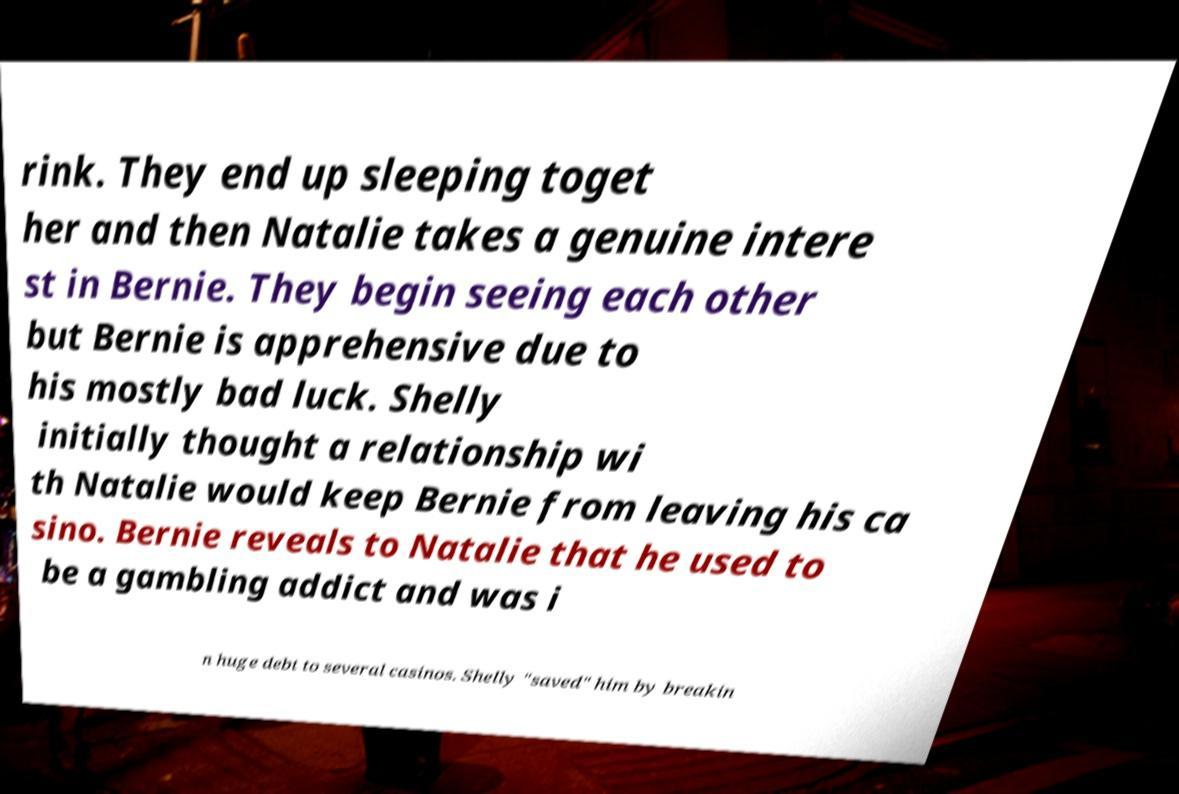Can you read and provide the text displayed in the image?This photo seems to have some interesting text. Can you extract and type it out for me? rink. They end up sleeping toget her and then Natalie takes a genuine intere st in Bernie. They begin seeing each other but Bernie is apprehensive due to his mostly bad luck. Shelly initially thought a relationship wi th Natalie would keep Bernie from leaving his ca sino. Bernie reveals to Natalie that he used to be a gambling addict and was i n huge debt to several casinos. Shelly "saved" him by breakin 